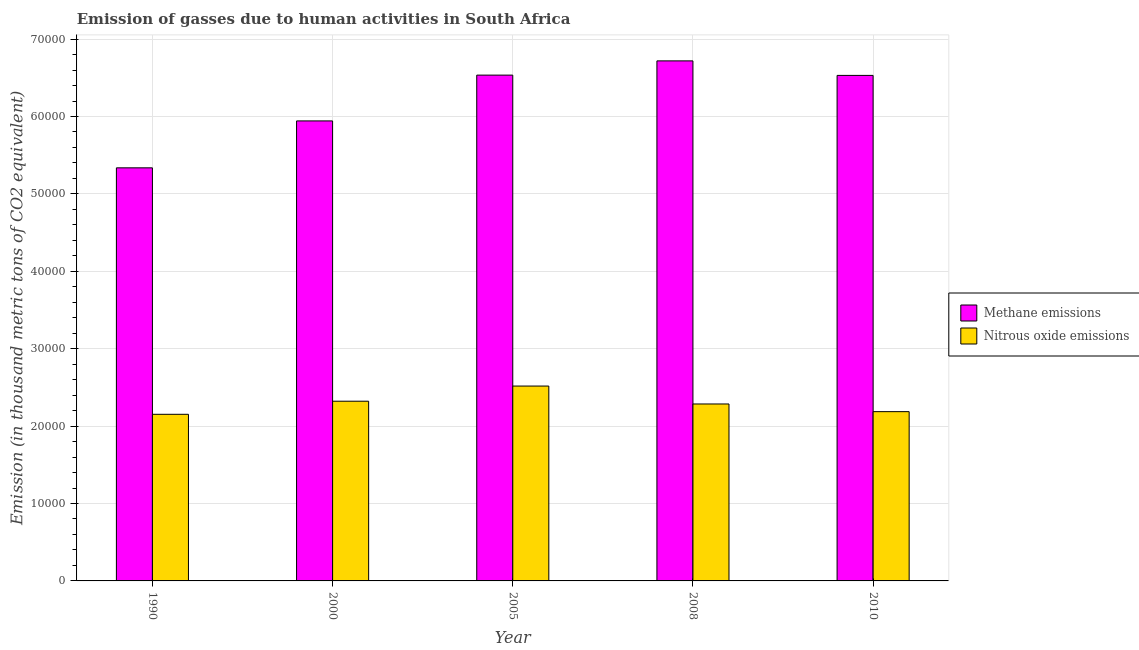Are the number of bars on each tick of the X-axis equal?
Keep it short and to the point. Yes. How many bars are there on the 3rd tick from the left?
Your answer should be very brief. 2. How many bars are there on the 4th tick from the right?
Give a very brief answer. 2. What is the amount of nitrous oxide emissions in 2008?
Offer a terse response. 2.29e+04. Across all years, what is the maximum amount of nitrous oxide emissions?
Make the answer very short. 2.52e+04. Across all years, what is the minimum amount of methane emissions?
Offer a terse response. 5.34e+04. What is the total amount of nitrous oxide emissions in the graph?
Ensure brevity in your answer.  1.15e+05. What is the difference between the amount of methane emissions in 2000 and that in 2005?
Ensure brevity in your answer.  -5917.5. What is the difference between the amount of methane emissions in 2008 and the amount of nitrous oxide emissions in 2010?
Keep it short and to the point. 1876. What is the average amount of nitrous oxide emissions per year?
Provide a succinct answer. 2.29e+04. What is the ratio of the amount of methane emissions in 2000 to that in 2010?
Make the answer very short. 0.91. What is the difference between the highest and the second highest amount of methane emissions?
Provide a short and direct response. 1839.7. What is the difference between the highest and the lowest amount of nitrous oxide emissions?
Ensure brevity in your answer.  3649.4. What does the 1st bar from the left in 2000 represents?
Provide a succinct answer. Methane emissions. What does the 1st bar from the right in 2000 represents?
Provide a succinct answer. Nitrous oxide emissions. How many bars are there?
Your response must be concise. 10. Are all the bars in the graph horizontal?
Offer a terse response. No. What is the difference between two consecutive major ticks on the Y-axis?
Your response must be concise. 10000. Does the graph contain any zero values?
Your answer should be compact. No. Does the graph contain grids?
Offer a terse response. Yes. What is the title of the graph?
Ensure brevity in your answer.  Emission of gasses due to human activities in South Africa. Does "From production" appear as one of the legend labels in the graph?
Give a very brief answer. No. What is the label or title of the X-axis?
Ensure brevity in your answer.  Year. What is the label or title of the Y-axis?
Make the answer very short. Emission (in thousand metric tons of CO2 equivalent). What is the Emission (in thousand metric tons of CO2 equivalent) of Methane emissions in 1990?
Make the answer very short. 5.34e+04. What is the Emission (in thousand metric tons of CO2 equivalent) in Nitrous oxide emissions in 1990?
Your answer should be very brief. 2.15e+04. What is the Emission (in thousand metric tons of CO2 equivalent) of Methane emissions in 2000?
Keep it short and to the point. 5.94e+04. What is the Emission (in thousand metric tons of CO2 equivalent) of Nitrous oxide emissions in 2000?
Your response must be concise. 2.32e+04. What is the Emission (in thousand metric tons of CO2 equivalent) of Methane emissions in 2005?
Offer a terse response. 6.53e+04. What is the Emission (in thousand metric tons of CO2 equivalent) in Nitrous oxide emissions in 2005?
Ensure brevity in your answer.  2.52e+04. What is the Emission (in thousand metric tons of CO2 equivalent) in Methane emissions in 2008?
Keep it short and to the point. 6.72e+04. What is the Emission (in thousand metric tons of CO2 equivalent) of Nitrous oxide emissions in 2008?
Keep it short and to the point. 2.29e+04. What is the Emission (in thousand metric tons of CO2 equivalent) of Methane emissions in 2010?
Keep it short and to the point. 6.53e+04. What is the Emission (in thousand metric tons of CO2 equivalent) in Nitrous oxide emissions in 2010?
Make the answer very short. 2.19e+04. Across all years, what is the maximum Emission (in thousand metric tons of CO2 equivalent) of Methane emissions?
Offer a terse response. 6.72e+04. Across all years, what is the maximum Emission (in thousand metric tons of CO2 equivalent) of Nitrous oxide emissions?
Your answer should be compact. 2.52e+04. Across all years, what is the minimum Emission (in thousand metric tons of CO2 equivalent) of Methane emissions?
Provide a succinct answer. 5.34e+04. Across all years, what is the minimum Emission (in thousand metric tons of CO2 equivalent) of Nitrous oxide emissions?
Provide a short and direct response. 2.15e+04. What is the total Emission (in thousand metric tons of CO2 equivalent) of Methane emissions in the graph?
Keep it short and to the point. 3.11e+05. What is the total Emission (in thousand metric tons of CO2 equivalent) in Nitrous oxide emissions in the graph?
Give a very brief answer. 1.15e+05. What is the difference between the Emission (in thousand metric tons of CO2 equivalent) of Methane emissions in 1990 and that in 2000?
Offer a terse response. -6061.3. What is the difference between the Emission (in thousand metric tons of CO2 equivalent) of Nitrous oxide emissions in 1990 and that in 2000?
Keep it short and to the point. -1690.3. What is the difference between the Emission (in thousand metric tons of CO2 equivalent) of Methane emissions in 1990 and that in 2005?
Your answer should be compact. -1.20e+04. What is the difference between the Emission (in thousand metric tons of CO2 equivalent) of Nitrous oxide emissions in 1990 and that in 2005?
Offer a very short reply. -3649.4. What is the difference between the Emission (in thousand metric tons of CO2 equivalent) in Methane emissions in 1990 and that in 2008?
Your response must be concise. -1.38e+04. What is the difference between the Emission (in thousand metric tons of CO2 equivalent) in Nitrous oxide emissions in 1990 and that in 2008?
Ensure brevity in your answer.  -1332.8. What is the difference between the Emission (in thousand metric tons of CO2 equivalent) of Methane emissions in 1990 and that in 2010?
Ensure brevity in your answer.  -1.19e+04. What is the difference between the Emission (in thousand metric tons of CO2 equivalent) in Nitrous oxide emissions in 1990 and that in 2010?
Give a very brief answer. -343.1. What is the difference between the Emission (in thousand metric tons of CO2 equivalent) of Methane emissions in 2000 and that in 2005?
Offer a terse response. -5917.5. What is the difference between the Emission (in thousand metric tons of CO2 equivalent) in Nitrous oxide emissions in 2000 and that in 2005?
Your response must be concise. -1959.1. What is the difference between the Emission (in thousand metric tons of CO2 equivalent) of Methane emissions in 2000 and that in 2008?
Your answer should be very brief. -7757.2. What is the difference between the Emission (in thousand metric tons of CO2 equivalent) of Nitrous oxide emissions in 2000 and that in 2008?
Offer a terse response. 357.5. What is the difference between the Emission (in thousand metric tons of CO2 equivalent) in Methane emissions in 2000 and that in 2010?
Your answer should be very brief. -5881.2. What is the difference between the Emission (in thousand metric tons of CO2 equivalent) of Nitrous oxide emissions in 2000 and that in 2010?
Give a very brief answer. 1347.2. What is the difference between the Emission (in thousand metric tons of CO2 equivalent) of Methane emissions in 2005 and that in 2008?
Make the answer very short. -1839.7. What is the difference between the Emission (in thousand metric tons of CO2 equivalent) in Nitrous oxide emissions in 2005 and that in 2008?
Your response must be concise. 2316.6. What is the difference between the Emission (in thousand metric tons of CO2 equivalent) of Methane emissions in 2005 and that in 2010?
Offer a terse response. 36.3. What is the difference between the Emission (in thousand metric tons of CO2 equivalent) of Nitrous oxide emissions in 2005 and that in 2010?
Your answer should be very brief. 3306.3. What is the difference between the Emission (in thousand metric tons of CO2 equivalent) of Methane emissions in 2008 and that in 2010?
Ensure brevity in your answer.  1876. What is the difference between the Emission (in thousand metric tons of CO2 equivalent) of Nitrous oxide emissions in 2008 and that in 2010?
Ensure brevity in your answer.  989.7. What is the difference between the Emission (in thousand metric tons of CO2 equivalent) in Methane emissions in 1990 and the Emission (in thousand metric tons of CO2 equivalent) in Nitrous oxide emissions in 2000?
Your answer should be very brief. 3.02e+04. What is the difference between the Emission (in thousand metric tons of CO2 equivalent) in Methane emissions in 1990 and the Emission (in thousand metric tons of CO2 equivalent) in Nitrous oxide emissions in 2005?
Provide a succinct answer. 2.82e+04. What is the difference between the Emission (in thousand metric tons of CO2 equivalent) in Methane emissions in 1990 and the Emission (in thousand metric tons of CO2 equivalent) in Nitrous oxide emissions in 2008?
Ensure brevity in your answer.  3.05e+04. What is the difference between the Emission (in thousand metric tons of CO2 equivalent) of Methane emissions in 1990 and the Emission (in thousand metric tons of CO2 equivalent) of Nitrous oxide emissions in 2010?
Provide a succinct answer. 3.15e+04. What is the difference between the Emission (in thousand metric tons of CO2 equivalent) in Methane emissions in 2000 and the Emission (in thousand metric tons of CO2 equivalent) in Nitrous oxide emissions in 2005?
Keep it short and to the point. 3.43e+04. What is the difference between the Emission (in thousand metric tons of CO2 equivalent) in Methane emissions in 2000 and the Emission (in thousand metric tons of CO2 equivalent) in Nitrous oxide emissions in 2008?
Offer a very short reply. 3.66e+04. What is the difference between the Emission (in thousand metric tons of CO2 equivalent) of Methane emissions in 2000 and the Emission (in thousand metric tons of CO2 equivalent) of Nitrous oxide emissions in 2010?
Give a very brief answer. 3.76e+04. What is the difference between the Emission (in thousand metric tons of CO2 equivalent) of Methane emissions in 2005 and the Emission (in thousand metric tons of CO2 equivalent) of Nitrous oxide emissions in 2008?
Ensure brevity in your answer.  4.25e+04. What is the difference between the Emission (in thousand metric tons of CO2 equivalent) of Methane emissions in 2005 and the Emission (in thousand metric tons of CO2 equivalent) of Nitrous oxide emissions in 2010?
Offer a terse response. 4.35e+04. What is the difference between the Emission (in thousand metric tons of CO2 equivalent) in Methane emissions in 2008 and the Emission (in thousand metric tons of CO2 equivalent) in Nitrous oxide emissions in 2010?
Your answer should be very brief. 4.53e+04. What is the average Emission (in thousand metric tons of CO2 equivalent) of Methane emissions per year?
Provide a short and direct response. 6.21e+04. What is the average Emission (in thousand metric tons of CO2 equivalent) of Nitrous oxide emissions per year?
Give a very brief answer. 2.29e+04. In the year 1990, what is the difference between the Emission (in thousand metric tons of CO2 equivalent) of Methane emissions and Emission (in thousand metric tons of CO2 equivalent) of Nitrous oxide emissions?
Your response must be concise. 3.18e+04. In the year 2000, what is the difference between the Emission (in thousand metric tons of CO2 equivalent) in Methane emissions and Emission (in thousand metric tons of CO2 equivalent) in Nitrous oxide emissions?
Give a very brief answer. 3.62e+04. In the year 2005, what is the difference between the Emission (in thousand metric tons of CO2 equivalent) in Methane emissions and Emission (in thousand metric tons of CO2 equivalent) in Nitrous oxide emissions?
Keep it short and to the point. 4.02e+04. In the year 2008, what is the difference between the Emission (in thousand metric tons of CO2 equivalent) of Methane emissions and Emission (in thousand metric tons of CO2 equivalent) of Nitrous oxide emissions?
Keep it short and to the point. 4.43e+04. In the year 2010, what is the difference between the Emission (in thousand metric tons of CO2 equivalent) in Methane emissions and Emission (in thousand metric tons of CO2 equivalent) in Nitrous oxide emissions?
Offer a very short reply. 4.34e+04. What is the ratio of the Emission (in thousand metric tons of CO2 equivalent) in Methane emissions in 1990 to that in 2000?
Provide a short and direct response. 0.9. What is the ratio of the Emission (in thousand metric tons of CO2 equivalent) in Nitrous oxide emissions in 1990 to that in 2000?
Provide a succinct answer. 0.93. What is the ratio of the Emission (in thousand metric tons of CO2 equivalent) of Methane emissions in 1990 to that in 2005?
Your answer should be very brief. 0.82. What is the ratio of the Emission (in thousand metric tons of CO2 equivalent) in Nitrous oxide emissions in 1990 to that in 2005?
Offer a very short reply. 0.85. What is the ratio of the Emission (in thousand metric tons of CO2 equivalent) of Methane emissions in 1990 to that in 2008?
Provide a short and direct response. 0.79. What is the ratio of the Emission (in thousand metric tons of CO2 equivalent) in Nitrous oxide emissions in 1990 to that in 2008?
Ensure brevity in your answer.  0.94. What is the ratio of the Emission (in thousand metric tons of CO2 equivalent) of Methane emissions in 1990 to that in 2010?
Provide a short and direct response. 0.82. What is the ratio of the Emission (in thousand metric tons of CO2 equivalent) of Nitrous oxide emissions in 1990 to that in 2010?
Your answer should be compact. 0.98. What is the ratio of the Emission (in thousand metric tons of CO2 equivalent) in Methane emissions in 2000 to that in 2005?
Your answer should be very brief. 0.91. What is the ratio of the Emission (in thousand metric tons of CO2 equivalent) in Nitrous oxide emissions in 2000 to that in 2005?
Keep it short and to the point. 0.92. What is the ratio of the Emission (in thousand metric tons of CO2 equivalent) in Methane emissions in 2000 to that in 2008?
Your response must be concise. 0.88. What is the ratio of the Emission (in thousand metric tons of CO2 equivalent) of Nitrous oxide emissions in 2000 to that in 2008?
Keep it short and to the point. 1.02. What is the ratio of the Emission (in thousand metric tons of CO2 equivalent) in Methane emissions in 2000 to that in 2010?
Ensure brevity in your answer.  0.91. What is the ratio of the Emission (in thousand metric tons of CO2 equivalent) of Nitrous oxide emissions in 2000 to that in 2010?
Provide a short and direct response. 1.06. What is the ratio of the Emission (in thousand metric tons of CO2 equivalent) of Methane emissions in 2005 to that in 2008?
Make the answer very short. 0.97. What is the ratio of the Emission (in thousand metric tons of CO2 equivalent) of Nitrous oxide emissions in 2005 to that in 2008?
Provide a succinct answer. 1.1. What is the ratio of the Emission (in thousand metric tons of CO2 equivalent) of Nitrous oxide emissions in 2005 to that in 2010?
Offer a very short reply. 1.15. What is the ratio of the Emission (in thousand metric tons of CO2 equivalent) of Methane emissions in 2008 to that in 2010?
Give a very brief answer. 1.03. What is the ratio of the Emission (in thousand metric tons of CO2 equivalent) of Nitrous oxide emissions in 2008 to that in 2010?
Ensure brevity in your answer.  1.05. What is the difference between the highest and the second highest Emission (in thousand metric tons of CO2 equivalent) of Methane emissions?
Provide a succinct answer. 1839.7. What is the difference between the highest and the second highest Emission (in thousand metric tons of CO2 equivalent) of Nitrous oxide emissions?
Provide a short and direct response. 1959.1. What is the difference between the highest and the lowest Emission (in thousand metric tons of CO2 equivalent) in Methane emissions?
Keep it short and to the point. 1.38e+04. What is the difference between the highest and the lowest Emission (in thousand metric tons of CO2 equivalent) in Nitrous oxide emissions?
Offer a terse response. 3649.4. 